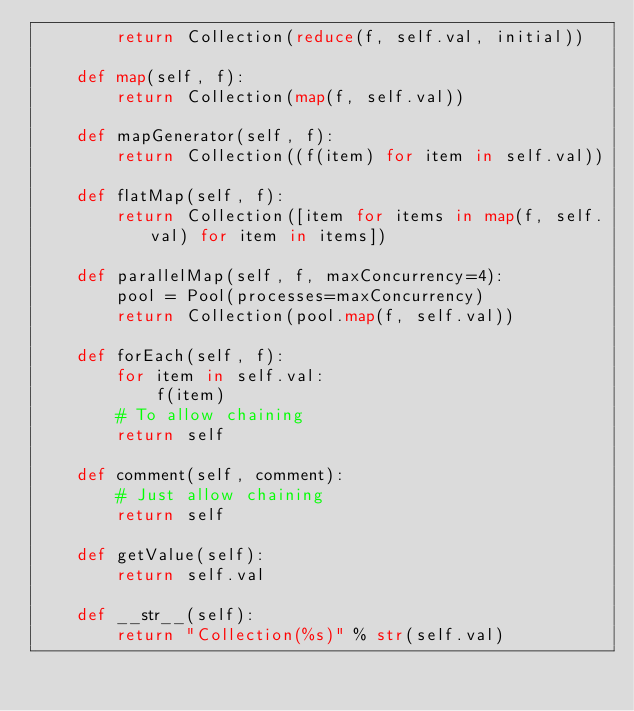Convert code to text. <code><loc_0><loc_0><loc_500><loc_500><_Python_>        return Collection(reduce(f, self.val, initial))

    def map(self, f):
        return Collection(map(f, self.val))

    def mapGenerator(self, f):
        return Collection((f(item) for item in self.val))

    def flatMap(self, f):
        return Collection([item for items in map(f, self.val) for item in items])

    def parallelMap(self, f, maxConcurrency=4):
        pool = Pool(processes=maxConcurrency)
        return Collection(pool.map(f, self.val))

    def forEach(self, f):
        for item in self.val:
            f(item)
        # To allow chaining
        return self

    def comment(self, comment):
        # Just allow chaining
        return self

    def getValue(self):
        return self.val

    def __str__(self):
        return "Collection(%s)" % str(self.val)
</code> 